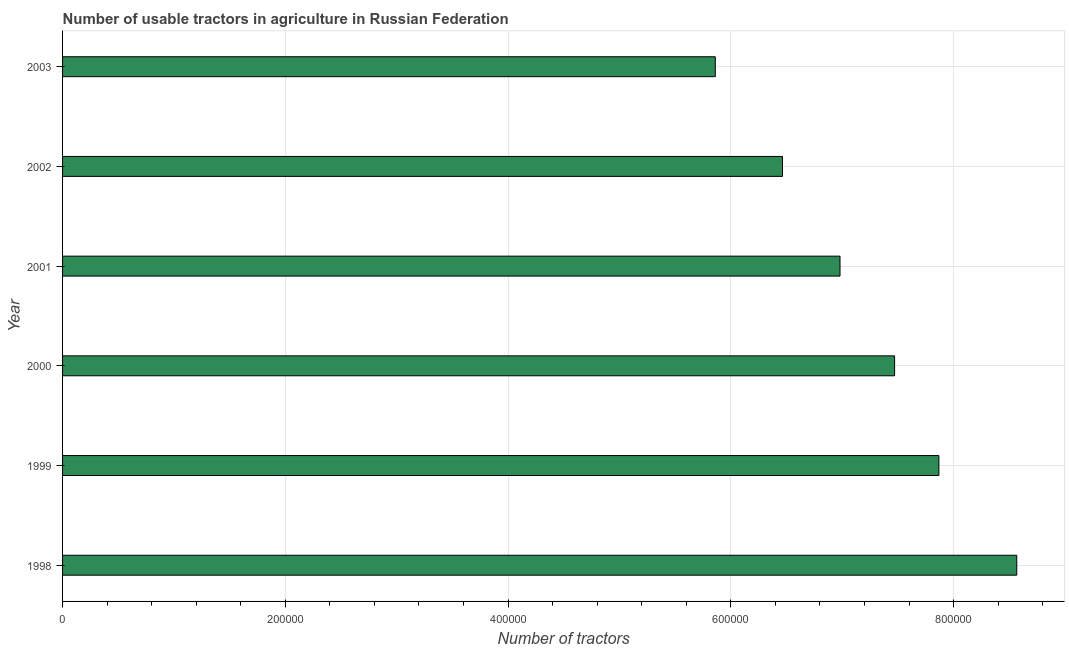Does the graph contain any zero values?
Keep it short and to the point. No. What is the title of the graph?
Provide a short and direct response. Number of usable tractors in agriculture in Russian Federation. What is the label or title of the X-axis?
Provide a succinct answer. Number of tractors. What is the number of tractors in 1998?
Provide a succinct answer. 8.57e+05. Across all years, what is the maximum number of tractors?
Offer a terse response. 8.57e+05. Across all years, what is the minimum number of tractors?
Provide a succinct answer. 5.86e+05. In which year was the number of tractors maximum?
Your response must be concise. 1998. What is the sum of the number of tractors?
Your response must be concise. 4.32e+06. What is the difference between the number of tractors in 1998 and 2001?
Provide a succinct answer. 1.59e+05. What is the average number of tractors per year?
Provide a succinct answer. 7.20e+05. What is the median number of tractors?
Your response must be concise. 7.22e+05. In how many years, is the number of tractors greater than 720000 ?
Your answer should be compact. 3. What is the ratio of the number of tractors in 1998 to that in 1999?
Your answer should be compact. 1.09. Is the number of tractors in 1998 less than that in 2003?
Provide a short and direct response. No. What is the difference between the highest and the second highest number of tractors?
Provide a short and direct response. 6.99e+04. What is the difference between the highest and the lowest number of tractors?
Provide a short and direct response. 2.71e+05. In how many years, is the number of tractors greater than the average number of tractors taken over all years?
Your answer should be very brief. 3. How many bars are there?
Your answer should be compact. 6. What is the Number of tractors in 1998?
Your response must be concise. 8.57e+05. What is the Number of tractors in 1999?
Offer a very short reply. 7.87e+05. What is the Number of tractors in 2000?
Ensure brevity in your answer.  7.47e+05. What is the Number of tractors of 2001?
Offer a very short reply. 6.98e+05. What is the Number of tractors in 2002?
Give a very brief answer. 6.46e+05. What is the Number of tractors of 2003?
Ensure brevity in your answer.  5.86e+05. What is the difference between the Number of tractors in 1998 and 1999?
Make the answer very short. 6.99e+04. What is the difference between the Number of tractors in 1998 and 2000?
Provide a succinct answer. 1.10e+05. What is the difference between the Number of tractors in 1998 and 2001?
Give a very brief answer. 1.59e+05. What is the difference between the Number of tractors in 1998 and 2002?
Give a very brief answer. 2.10e+05. What is the difference between the Number of tractors in 1998 and 2003?
Offer a terse response. 2.71e+05. What is the difference between the Number of tractors in 1999 and 2000?
Give a very brief answer. 3.98e+04. What is the difference between the Number of tractors in 1999 and 2001?
Provide a succinct answer. 8.88e+04. What is the difference between the Number of tractors in 1999 and 2002?
Provide a succinct answer. 1.40e+05. What is the difference between the Number of tractors in 1999 and 2003?
Provide a short and direct response. 2.01e+05. What is the difference between the Number of tractors in 2000 and 2001?
Provide a short and direct response. 4.90e+04. What is the difference between the Number of tractors in 2000 and 2002?
Your answer should be very brief. 1.01e+05. What is the difference between the Number of tractors in 2000 and 2003?
Your answer should be very brief. 1.61e+05. What is the difference between the Number of tractors in 2001 and 2002?
Keep it short and to the point. 5.16e+04. What is the difference between the Number of tractors in 2001 and 2003?
Give a very brief answer. 1.12e+05. What is the difference between the Number of tractors in 2002 and 2003?
Provide a short and direct response. 6.03e+04. What is the ratio of the Number of tractors in 1998 to that in 1999?
Ensure brevity in your answer.  1.09. What is the ratio of the Number of tractors in 1998 to that in 2000?
Your response must be concise. 1.15. What is the ratio of the Number of tractors in 1998 to that in 2001?
Keep it short and to the point. 1.23. What is the ratio of the Number of tractors in 1998 to that in 2002?
Your answer should be compact. 1.32. What is the ratio of the Number of tractors in 1998 to that in 2003?
Offer a very short reply. 1.46. What is the ratio of the Number of tractors in 1999 to that in 2000?
Provide a short and direct response. 1.05. What is the ratio of the Number of tractors in 1999 to that in 2001?
Your answer should be compact. 1.13. What is the ratio of the Number of tractors in 1999 to that in 2002?
Your answer should be compact. 1.22. What is the ratio of the Number of tractors in 1999 to that in 2003?
Offer a very short reply. 1.34. What is the ratio of the Number of tractors in 2000 to that in 2001?
Offer a terse response. 1.07. What is the ratio of the Number of tractors in 2000 to that in 2002?
Give a very brief answer. 1.16. What is the ratio of the Number of tractors in 2000 to that in 2003?
Your response must be concise. 1.27. What is the ratio of the Number of tractors in 2001 to that in 2002?
Your answer should be compact. 1.08. What is the ratio of the Number of tractors in 2001 to that in 2003?
Your response must be concise. 1.19. What is the ratio of the Number of tractors in 2002 to that in 2003?
Your answer should be very brief. 1.1. 